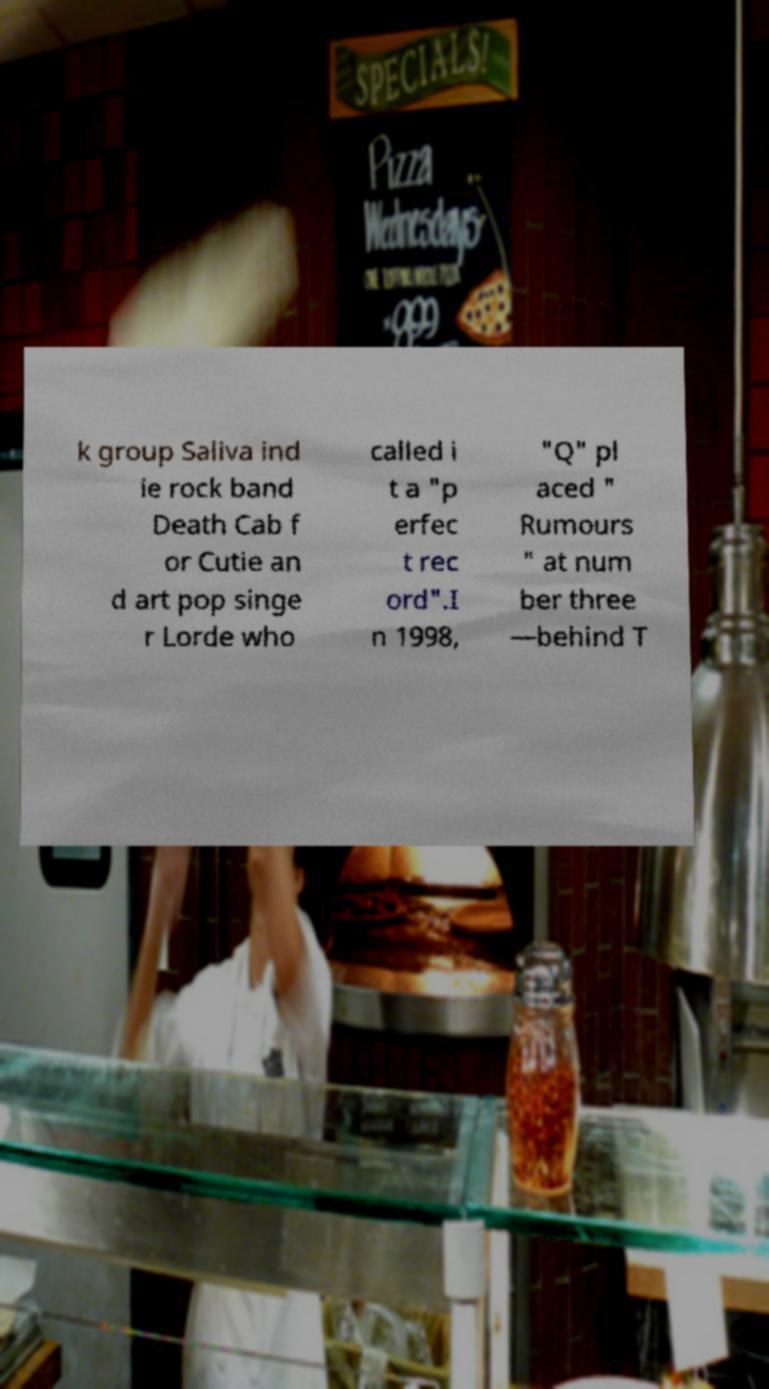Please identify and transcribe the text found in this image. k group Saliva ind ie rock band Death Cab f or Cutie an d art pop singe r Lorde who called i t a "p erfec t rec ord".I n 1998, "Q" pl aced " Rumours " at num ber three —behind T 